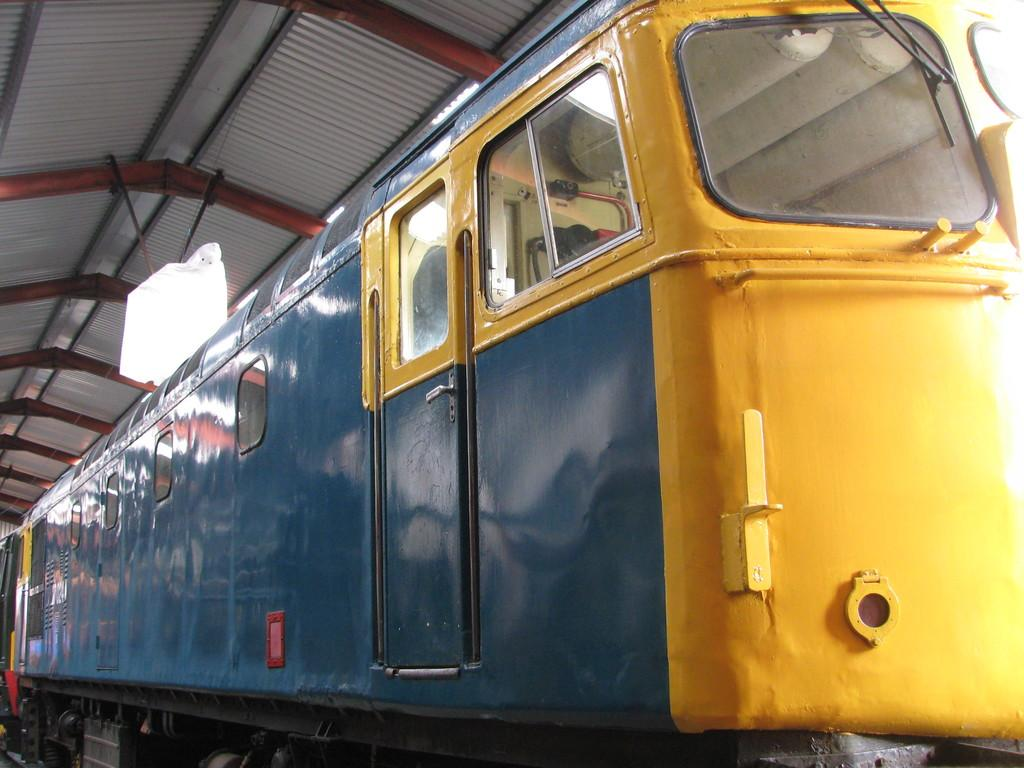What colors are the trains in the image? There is a yellow train and a blue train in the image. What feature is present at the top of the trains? There is a light at the top of the trains. What material is used for the roofs of the trains? The trains have tin roofs. Can you tell me how many girls are riding the yellow train in the image? There is no girl present in the image; it only features the yellow and blue trains with lights and tin roofs. What type of snack is being served on the trains in the image? There is no snack, such as popcorn, present in the image; it only features the trains with lights and tin roofs. 